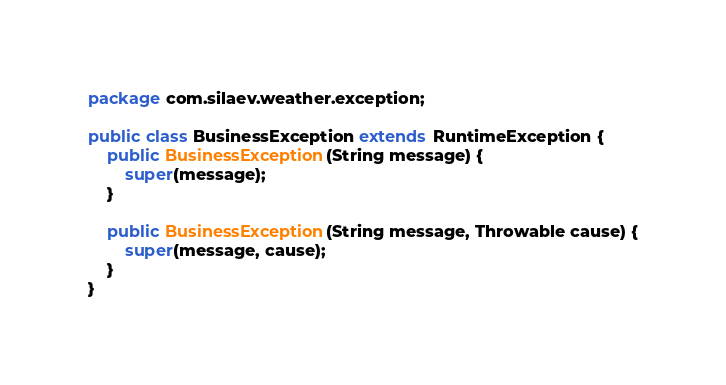Convert code to text. <code><loc_0><loc_0><loc_500><loc_500><_Java_>package com.silaev.weather.exception;

public class BusinessException extends RuntimeException {
    public BusinessException(String message) {
        super(message);
    }

    public BusinessException(String message, Throwable cause) {
        super(message, cause);
    }
}
</code> 